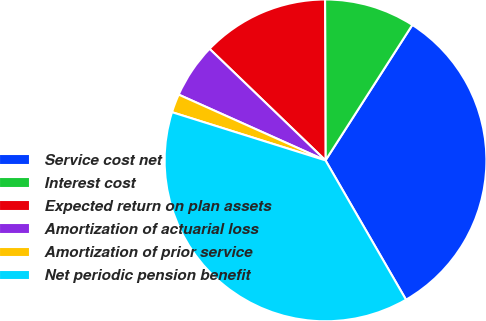<chart> <loc_0><loc_0><loc_500><loc_500><pie_chart><fcel>Service cost net<fcel>Interest cost<fcel>Expected return on plan assets<fcel>Amortization of actuarial loss<fcel>Amortization of prior service<fcel>Net periodic pension benefit<nl><fcel>32.59%<fcel>9.12%<fcel>12.76%<fcel>5.49%<fcel>1.86%<fcel>38.18%<nl></chart> 